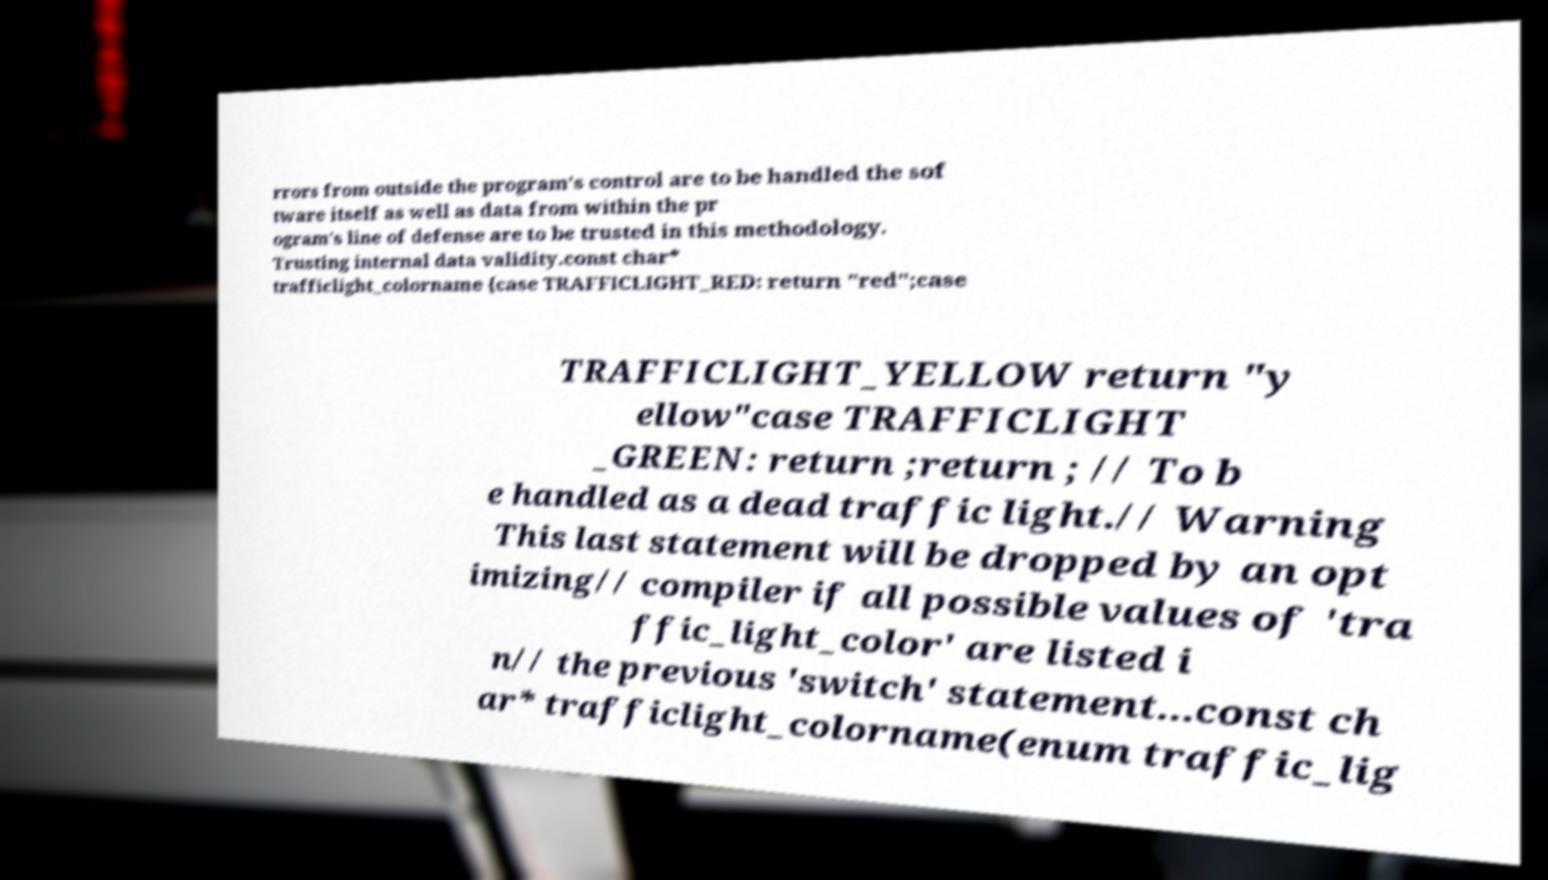Could you extract and type out the text from this image? rrors from outside the program's control are to be handled the sof tware itself as well as data from within the pr ogram's line of defense are to be trusted in this methodology. Trusting internal data validity.const char* trafficlight_colorname {case TRAFFICLIGHT_RED: return "red";case TRAFFICLIGHT_YELLOW return "y ellow"case TRAFFICLIGHT _GREEN: return ;return ; // To b e handled as a dead traffic light.// Warning This last statement will be dropped by an opt imizing// compiler if all possible values of 'tra ffic_light_color' are listed i n// the previous 'switch' statement...const ch ar* trafficlight_colorname(enum traffic_lig 